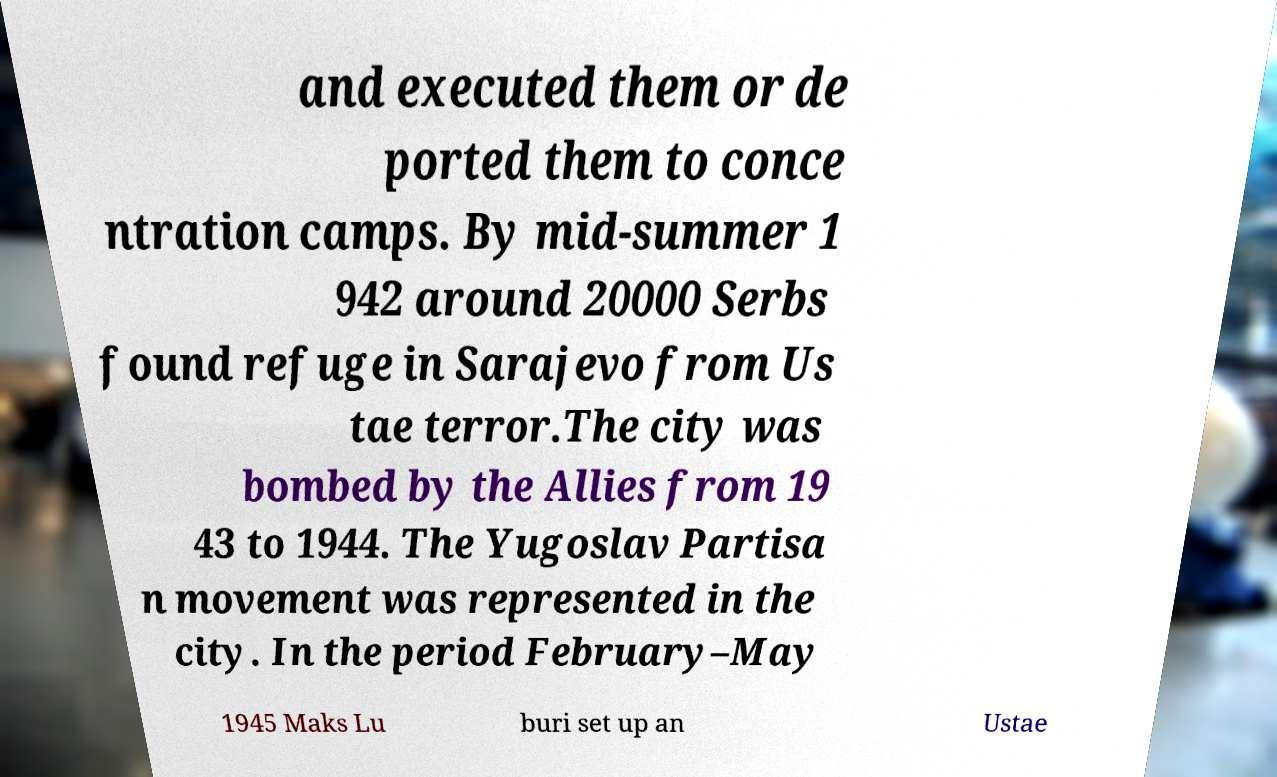Could you assist in decoding the text presented in this image and type it out clearly? and executed them or de ported them to conce ntration camps. By mid-summer 1 942 around 20000 Serbs found refuge in Sarajevo from Us tae terror.The city was bombed by the Allies from 19 43 to 1944. The Yugoslav Partisa n movement was represented in the city. In the period February–May 1945 Maks Lu buri set up an Ustae 